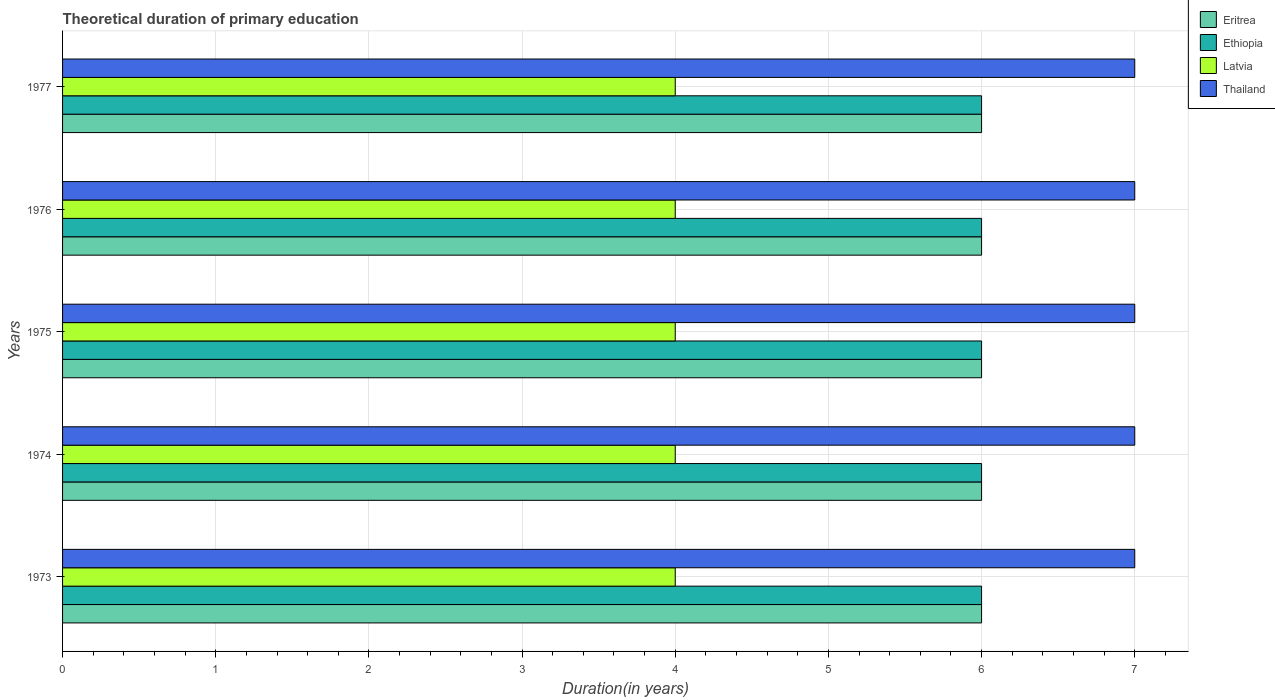How many bars are there on the 4th tick from the bottom?
Give a very brief answer. 4. What is the label of the 4th group of bars from the top?
Offer a terse response. 1974. In how many cases, is the number of bars for a given year not equal to the number of legend labels?
Provide a short and direct response. 0. What is the total theoretical duration of primary education in Ethiopia in 1974?
Your answer should be compact. 6. Across all years, what is the maximum total theoretical duration of primary education in Thailand?
Offer a very short reply. 7. Across all years, what is the minimum total theoretical duration of primary education in Latvia?
Your answer should be very brief. 4. In which year was the total theoretical duration of primary education in Thailand maximum?
Make the answer very short. 1973. In which year was the total theoretical duration of primary education in Ethiopia minimum?
Offer a terse response. 1973. What is the total total theoretical duration of primary education in Latvia in the graph?
Your answer should be very brief. 20. What is the difference between the total theoretical duration of primary education in Ethiopia in 1975 and the total theoretical duration of primary education in Latvia in 1974?
Provide a short and direct response. 2. What is the average total theoretical duration of primary education in Ethiopia per year?
Ensure brevity in your answer.  6. In the year 1977, what is the difference between the total theoretical duration of primary education in Ethiopia and total theoretical duration of primary education in Thailand?
Provide a succinct answer. -1. What is the difference between the highest and the second highest total theoretical duration of primary education in Eritrea?
Your response must be concise. 0. What is the difference between the highest and the lowest total theoretical duration of primary education in Ethiopia?
Keep it short and to the point. 0. In how many years, is the total theoretical duration of primary education in Thailand greater than the average total theoretical duration of primary education in Thailand taken over all years?
Provide a succinct answer. 0. Is the sum of the total theoretical duration of primary education in Ethiopia in 1974 and 1976 greater than the maximum total theoretical duration of primary education in Eritrea across all years?
Offer a terse response. Yes. Is it the case that in every year, the sum of the total theoretical duration of primary education in Thailand and total theoretical duration of primary education in Eritrea is greater than the sum of total theoretical duration of primary education in Latvia and total theoretical duration of primary education in Ethiopia?
Offer a very short reply. No. What does the 2nd bar from the top in 1974 represents?
Your answer should be very brief. Latvia. What does the 4th bar from the bottom in 1974 represents?
Ensure brevity in your answer.  Thailand. Is it the case that in every year, the sum of the total theoretical duration of primary education in Eritrea and total theoretical duration of primary education in Ethiopia is greater than the total theoretical duration of primary education in Latvia?
Provide a succinct answer. Yes. How many bars are there?
Your response must be concise. 20. Are all the bars in the graph horizontal?
Provide a short and direct response. Yes. Are the values on the major ticks of X-axis written in scientific E-notation?
Offer a very short reply. No. Does the graph contain grids?
Ensure brevity in your answer.  Yes. How many legend labels are there?
Provide a short and direct response. 4. What is the title of the graph?
Your response must be concise. Theoretical duration of primary education. What is the label or title of the X-axis?
Your answer should be compact. Duration(in years). What is the Duration(in years) of Latvia in 1973?
Provide a short and direct response. 4. What is the Duration(in years) of Latvia in 1974?
Make the answer very short. 4. What is the Duration(in years) of Eritrea in 1975?
Your response must be concise. 6. What is the Duration(in years) in Thailand in 1975?
Keep it short and to the point. 7. What is the Duration(in years) of Eritrea in 1976?
Make the answer very short. 6. What is the Duration(in years) in Thailand in 1976?
Give a very brief answer. 7. What is the Duration(in years) in Eritrea in 1977?
Ensure brevity in your answer.  6. What is the Duration(in years) of Ethiopia in 1977?
Offer a very short reply. 6. What is the Duration(in years) of Latvia in 1977?
Make the answer very short. 4. What is the Duration(in years) of Thailand in 1977?
Your answer should be very brief. 7. Across all years, what is the maximum Duration(in years) of Eritrea?
Offer a terse response. 6. Across all years, what is the maximum Duration(in years) in Ethiopia?
Ensure brevity in your answer.  6. Across all years, what is the maximum Duration(in years) of Latvia?
Make the answer very short. 4. Across all years, what is the maximum Duration(in years) of Thailand?
Keep it short and to the point. 7. What is the total Duration(in years) of Ethiopia in the graph?
Offer a very short reply. 30. What is the total Duration(in years) of Latvia in the graph?
Provide a succinct answer. 20. What is the total Duration(in years) in Thailand in the graph?
Make the answer very short. 35. What is the difference between the Duration(in years) of Ethiopia in 1973 and that in 1974?
Your response must be concise. 0. What is the difference between the Duration(in years) of Thailand in 1973 and that in 1974?
Provide a succinct answer. 0. What is the difference between the Duration(in years) in Eritrea in 1973 and that in 1975?
Make the answer very short. 0. What is the difference between the Duration(in years) in Ethiopia in 1973 and that in 1975?
Keep it short and to the point. 0. What is the difference between the Duration(in years) in Latvia in 1973 and that in 1975?
Offer a terse response. 0. What is the difference between the Duration(in years) in Thailand in 1973 and that in 1976?
Give a very brief answer. 0. What is the difference between the Duration(in years) of Eritrea in 1973 and that in 1977?
Offer a very short reply. 0. What is the difference between the Duration(in years) of Latvia in 1973 and that in 1977?
Ensure brevity in your answer.  0. What is the difference between the Duration(in years) in Thailand in 1973 and that in 1977?
Make the answer very short. 0. What is the difference between the Duration(in years) of Eritrea in 1974 and that in 1975?
Offer a terse response. 0. What is the difference between the Duration(in years) in Latvia in 1974 and that in 1975?
Provide a succinct answer. 0. What is the difference between the Duration(in years) in Thailand in 1974 and that in 1975?
Keep it short and to the point. 0. What is the difference between the Duration(in years) in Eritrea in 1974 and that in 1976?
Your response must be concise. 0. What is the difference between the Duration(in years) in Latvia in 1974 and that in 1976?
Keep it short and to the point. 0. What is the difference between the Duration(in years) of Thailand in 1974 and that in 1976?
Offer a terse response. 0. What is the difference between the Duration(in years) in Latvia in 1974 and that in 1977?
Your answer should be very brief. 0. What is the difference between the Duration(in years) in Thailand in 1974 and that in 1977?
Your response must be concise. 0. What is the difference between the Duration(in years) of Eritrea in 1975 and that in 1977?
Provide a succinct answer. 0. What is the difference between the Duration(in years) in Ethiopia in 1975 and that in 1977?
Make the answer very short. 0. What is the difference between the Duration(in years) in Latvia in 1975 and that in 1977?
Provide a short and direct response. 0. What is the difference between the Duration(in years) of Thailand in 1975 and that in 1977?
Provide a short and direct response. 0. What is the difference between the Duration(in years) of Eritrea in 1976 and that in 1977?
Ensure brevity in your answer.  0. What is the difference between the Duration(in years) of Ethiopia in 1976 and that in 1977?
Ensure brevity in your answer.  0. What is the difference between the Duration(in years) in Ethiopia in 1973 and the Duration(in years) in Thailand in 1974?
Provide a short and direct response. -1. What is the difference between the Duration(in years) in Eritrea in 1973 and the Duration(in years) in Ethiopia in 1975?
Your answer should be compact. 0. What is the difference between the Duration(in years) in Eritrea in 1973 and the Duration(in years) in Ethiopia in 1976?
Your response must be concise. 0. What is the difference between the Duration(in years) of Eritrea in 1973 and the Duration(in years) of Thailand in 1976?
Make the answer very short. -1. What is the difference between the Duration(in years) in Ethiopia in 1973 and the Duration(in years) in Latvia in 1976?
Provide a succinct answer. 2. What is the difference between the Duration(in years) of Eritrea in 1973 and the Duration(in years) of Thailand in 1977?
Provide a succinct answer. -1. What is the difference between the Duration(in years) in Eritrea in 1974 and the Duration(in years) in Ethiopia in 1975?
Provide a succinct answer. 0. What is the difference between the Duration(in years) in Ethiopia in 1974 and the Duration(in years) in Latvia in 1975?
Make the answer very short. 2. What is the difference between the Duration(in years) of Ethiopia in 1974 and the Duration(in years) of Thailand in 1975?
Your answer should be very brief. -1. What is the difference between the Duration(in years) in Eritrea in 1974 and the Duration(in years) in Thailand in 1976?
Keep it short and to the point. -1. What is the difference between the Duration(in years) in Ethiopia in 1974 and the Duration(in years) in Latvia in 1976?
Offer a terse response. 2. What is the difference between the Duration(in years) in Ethiopia in 1974 and the Duration(in years) in Thailand in 1976?
Make the answer very short. -1. What is the difference between the Duration(in years) in Eritrea in 1974 and the Duration(in years) in Latvia in 1977?
Give a very brief answer. 2. What is the difference between the Duration(in years) of Latvia in 1974 and the Duration(in years) of Thailand in 1977?
Give a very brief answer. -3. What is the difference between the Duration(in years) in Eritrea in 1975 and the Duration(in years) in Latvia in 1976?
Offer a very short reply. 2. What is the difference between the Duration(in years) of Ethiopia in 1975 and the Duration(in years) of Thailand in 1976?
Provide a succinct answer. -1. What is the difference between the Duration(in years) in Eritrea in 1975 and the Duration(in years) in Ethiopia in 1977?
Provide a short and direct response. 0. What is the difference between the Duration(in years) in Ethiopia in 1975 and the Duration(in years) in Latvia in 1977?
Offer a terse response. 2. What is the difference between the Duration(in years) of Latvia in 1975 and the Duration(in years) of Thailand in 1977?
Offer a terse response. -3. What is the difference between the Duration(in years) in Eritrea in 1976 and the Duration(in years) in Thailand in 1977?
Your answer should be compact. -1. What is the difference between the Duration(in years) of Ethiopia in 1976 and the Duration(in years) of Latvia in 1977?
Offer a terse response. 2. What is the difference between the Duration(in years) in Ethiopia in 1976 and the Duration(in years) in Thailand in 1977?
Give a very brief answer. -1. What is the average Duration(in years) of Eritrea per year?
Provide a short and direct response. 6. In the year 1973, what is the difference between the Duration(in years) of Eritrea and Duration(in years) of Thailand?
Make the answer very short. -1. In the year 1973, what is the difference between the Duration(in years) of Ethiopia and Duration(in years) of Thailand?
Ensure brevity in your answer.  -1. In the year 1974, what is the difference between the Duration(in years) in Eritrea and Duration(in years) in Latvia?
Give a very brief answer. 2. In the year 1974, what is the difference between the Duration(in years) in Eritrea and Duration(in years) in Thailand?
Provide a succinct answer. -1. In the year 1974, what is the difference between the Duration(in years) in Ethiopia and Duration(in years) in Latvia?
Your response must be concise. 2. In the year 1974, what is the difference between the Duration(in years) in Ethiopia and Duration(in years) in Thailand?
Keep it short and to the point. -1. In the year 1974, what is the difference between the Duration(in years) of Latvia and Duration(in years) of Thailand?
Keep it short and to the point. -3. In the year 1975, what is the difference between the Duration(in years) of Latvia and Duration(in years) of Thailand?
Provide a succinct answer. -3. In the year 1976, what is the difference between the Duration(in years) of Eritrea and Duration(in years) of Thailand?
Provide a short and direct response. -1. In the year 1976, what is the difference between the Duration(in years) in Ethiopia and Duration(in years) in Latvia?
Provide a short and direct response. 2. In the year 1977, what is the difference between the Duration(in years) in Eritrea and Duration(in years) in Latvia?
Provide a short and direct response. 2. What is the ratio of the Duration(in years) in Eritrea in 1973 to that in 1974?
Offer a terse response. 1. What is the ratio of the Duration(in years) of Latvia in 1973 to that in 1974?
Keep it short and to the point. 1. What is the ratio of the Duration(in years) of Thailand in 1973 to that in 1974?
Your answer should be compact. 1. What is the ratio of the Duration(in years) of Eritrea in 1973 to that in 1975?
Your answer should be very brief. 1. What is the ratio of the Duration(in years) of Latvia in 1973 to that in 1975?
Provide a succinct answer. 1. What is the ratio of the Duration(in years) in Eritrea in 1973 to that in 1976?
Your response must be concise. 1. What is the ratio of the Duration(in years) in Thailand in 1973 to that in 1976?
Provide a succinct answer. 1. What is the ratio of the Duration(in years) in Eritrea in 1973 to that in 1977?
Your answer should be compact. 1. What is the ratio of the Duration(in years) of Latvia in 1973 to that in 1977?
Your response must be concise. 1. What is the ratio of the Duration(in years) of Eritrea in 1974 to that in 1975?
Provide a short and direct response. 1. What is the ratio of the Duration(in years) of Ethiopia in 1974 to that in 1975?
Make the answer very short. 1. What is the ratio of the Duration(in years) of Thailand in 1974 to that in 1975?
Offer a terse response. 1. What is the ratio of the Duration(in years) in Ethiopia in 1974 to that in 1976?
Provide a succinct answer. 1. What is the ratio of the Duration(in years) in Latvia in 1974 to that in 1976?
Keep it short and to the point. 1. What is the ratio of the Duration(in years) of Thailand in 1974 to that in 1976?
Provide a short and direct response. 1. What is the ratio of the Duration(in years) in Ethiopia in 1974 to that in 1977?
Make the answer very short. 1. What is the ratio of the Duration(in years) of Thailand in 1974 to that in 1977?
Offer a very short reply. 1. What is the ratio of the Duration(in years) of Latvia in 1975 to that in 1976?
Ensure brevity in your answer.  1. What is the ratio of the Duration(in years) of Eritrea in 1975 to that in 1977?
Provide a succinct answer. 1. What is the ratio of the Duration(in years) of Ethiopia in 1975 to that in 1977?
Offer a terse response. 1. What is the ratio of the Duration(in years) of Thailand in 1976 to that in 1977?
Give a very brief answer. 1. What is the difference between the highest and the second highest Duration(in years) in Eritrea?
Offer a terse response. 0. What is the difference between the highest and the second highest Duration(in years) of Ethiopia?
Provide a short and direct response. 0. What is the difference between the highest and the second highest Duration(in years) of Latvia?
Your answer should be very brief. 0. What is the difference between the highest and the second highest Duration(in years) in Thailand?
Provide a short and direct response. 0. What is the difference between the highest and the lowest Duration(in years) of Eritrea?
Offer a terse response. 0. What is the difference between the highest and the lowest Duration(in years) of Latvia?
Provide a short and direct response. 0. What is the difference between the highest and the lowest Duration(in years) of Thailand?
Provide a succinct answer. 0. 